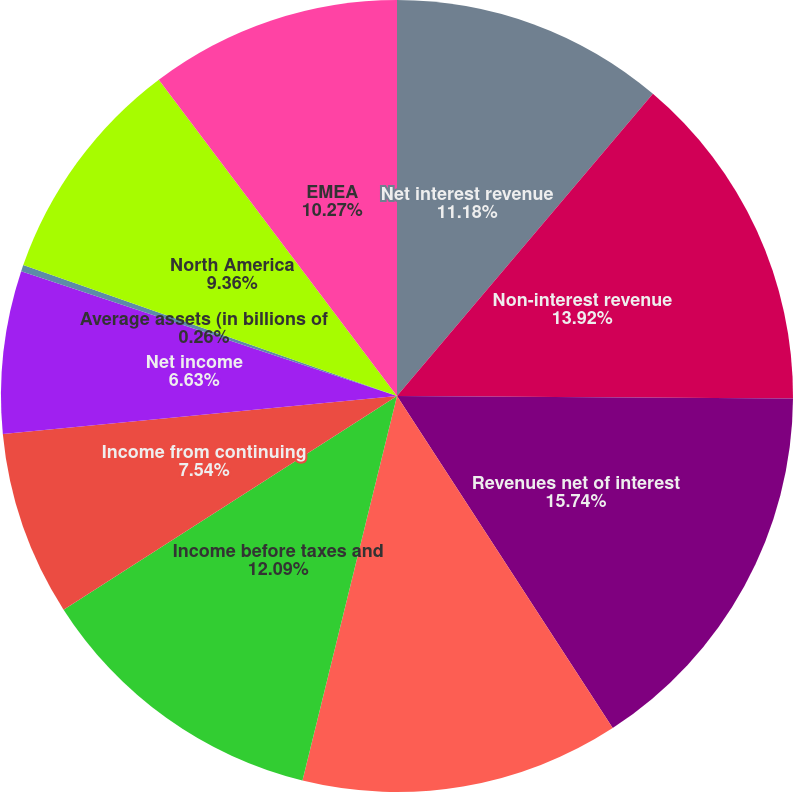<chart> <loc_0><loc_0><loc_500><loc_500><pie_chart><fcel>Net interest revenue<fcel>Non-interest revenue<fcel>Revenues net of interest<fcel>Total operating expenses<fcel>Income before taxes and<fcel>Income from continuing<fcel>Net income<fcel>Average assets (in billions of<fcel>North America<fcel>EMEA<nl><fcel>11.18%<fcel>13.91%<fcel>15.73%<fcel>13.0%<fcel>12.09%<fcel>7.54%<fcel>6.63%<fcel>0.26%<fcel>9.36%<fcel>10.27%<nl></chart> 